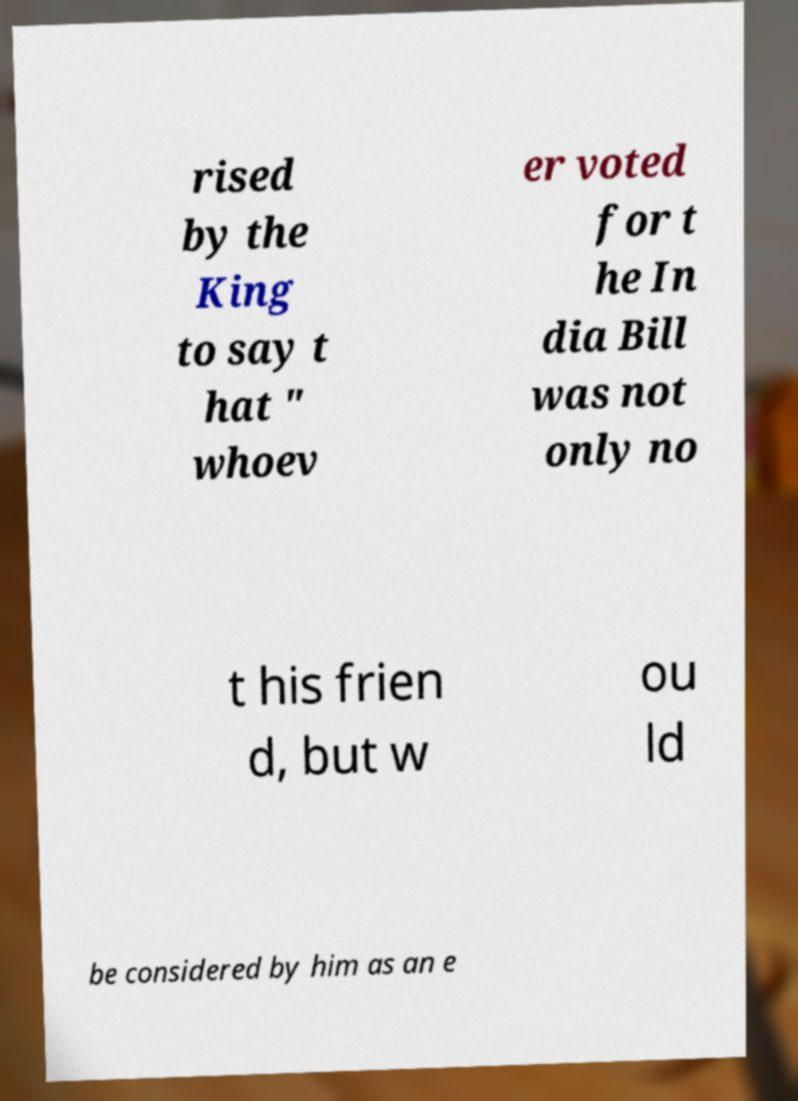Could you assist in decoding the text presented in this image and type it out clearly? rised by the King to say t hat " whoev er voted for t he In dia Bill was not only no t his frien d, but w ou ld be considered by him as an e 